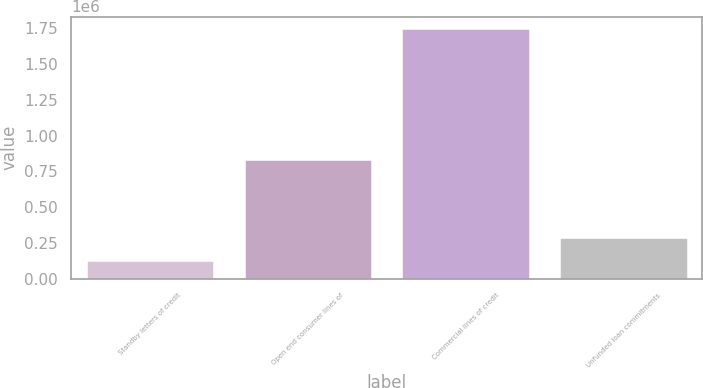Convert chart. <chart><loc_0><loc_0><loc_500><loc_500><bar_chart><fcel>Standby letters of credit<fcel>Open end consumer lines of<fcel>Commercial lines of credit<fcel>Unfunded loan commitments<nl><fcel>122672<fcel>829923<fcel>1.74359e+06<fcel>284764<nl></chart> 